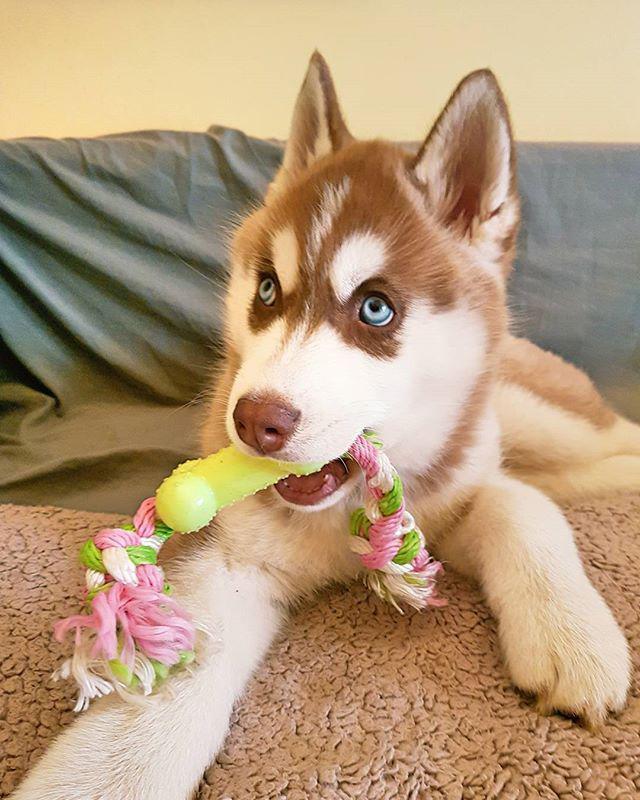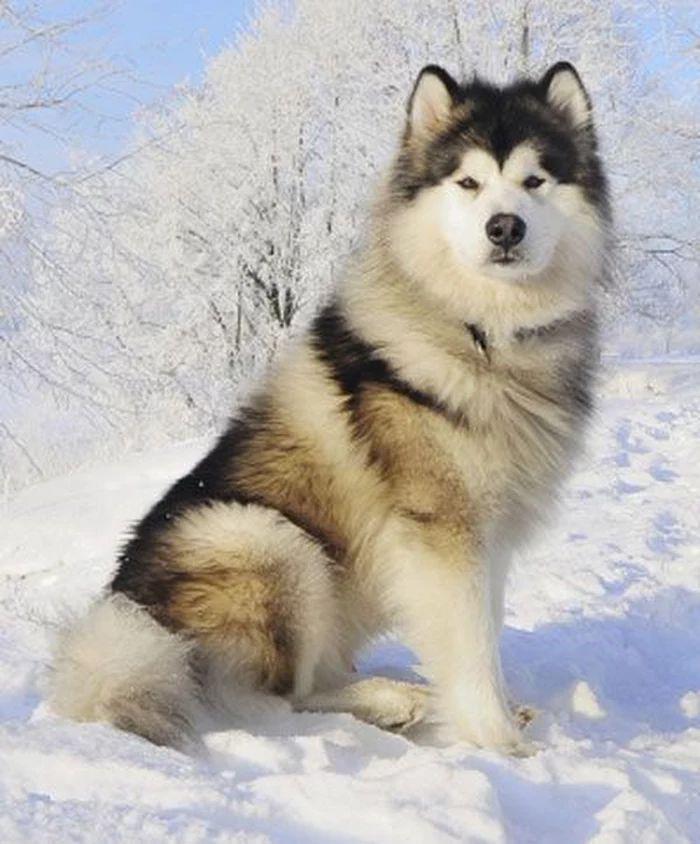The first image is the image on the left, the second image is the image on the right. Given the left and right images, does the statement "At least one Malamute is sitting in the snow." hold true? Answer yes or no. Yes. The first image is the image on the left, the second image is the image on the right. For the images displayed, is the sentence "The right image shows a non-standing adult husky dog with its head upright, and the left image shows a husky puppy with its head down but its eyes gazing upward." factually correct? Answer yes or no. Yes. 